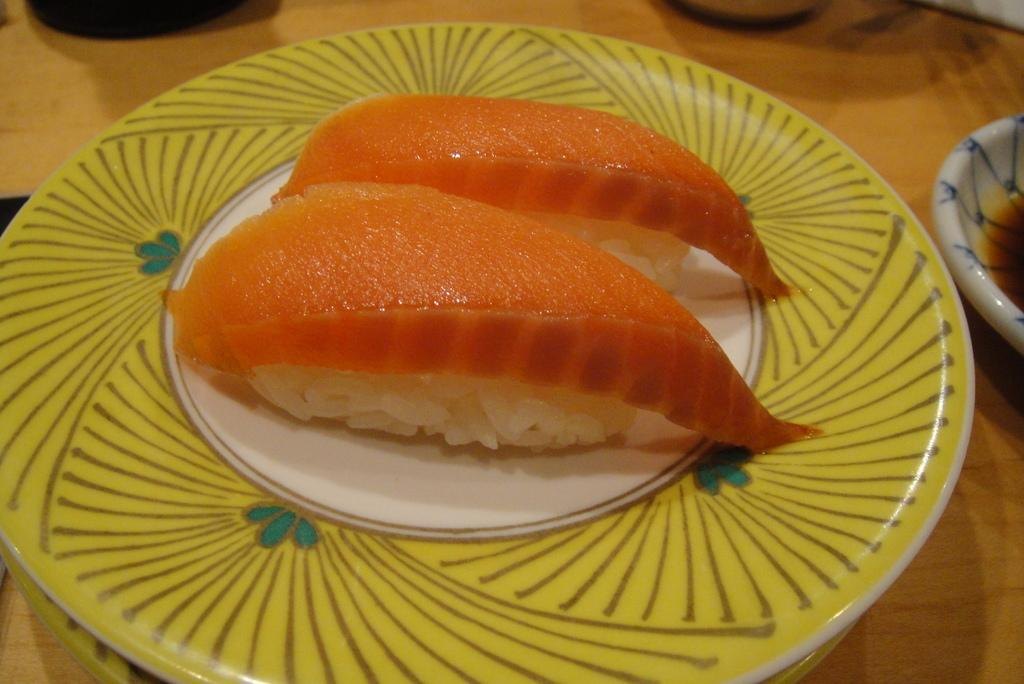What is the main food item visible on a plate in the image? The specific food item is not mentioned, but there is a food item on a plate in the image. What type of containers are present in the image? There are bowls in the image. What type of furniture is visible in the image? There are objects on a wooden table in the image. Can you hear the grandfather's bells ringing in the yard in the image? There is no mention of a grandfather, bells, or a yard in the image, so it is not possible to answer that question. 